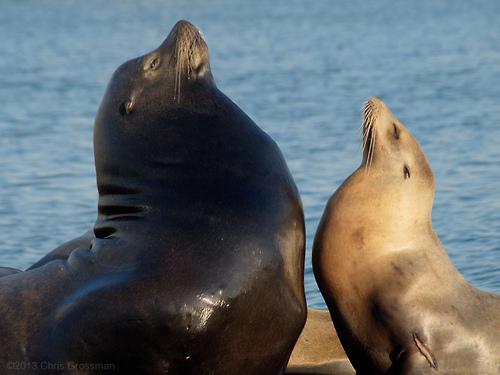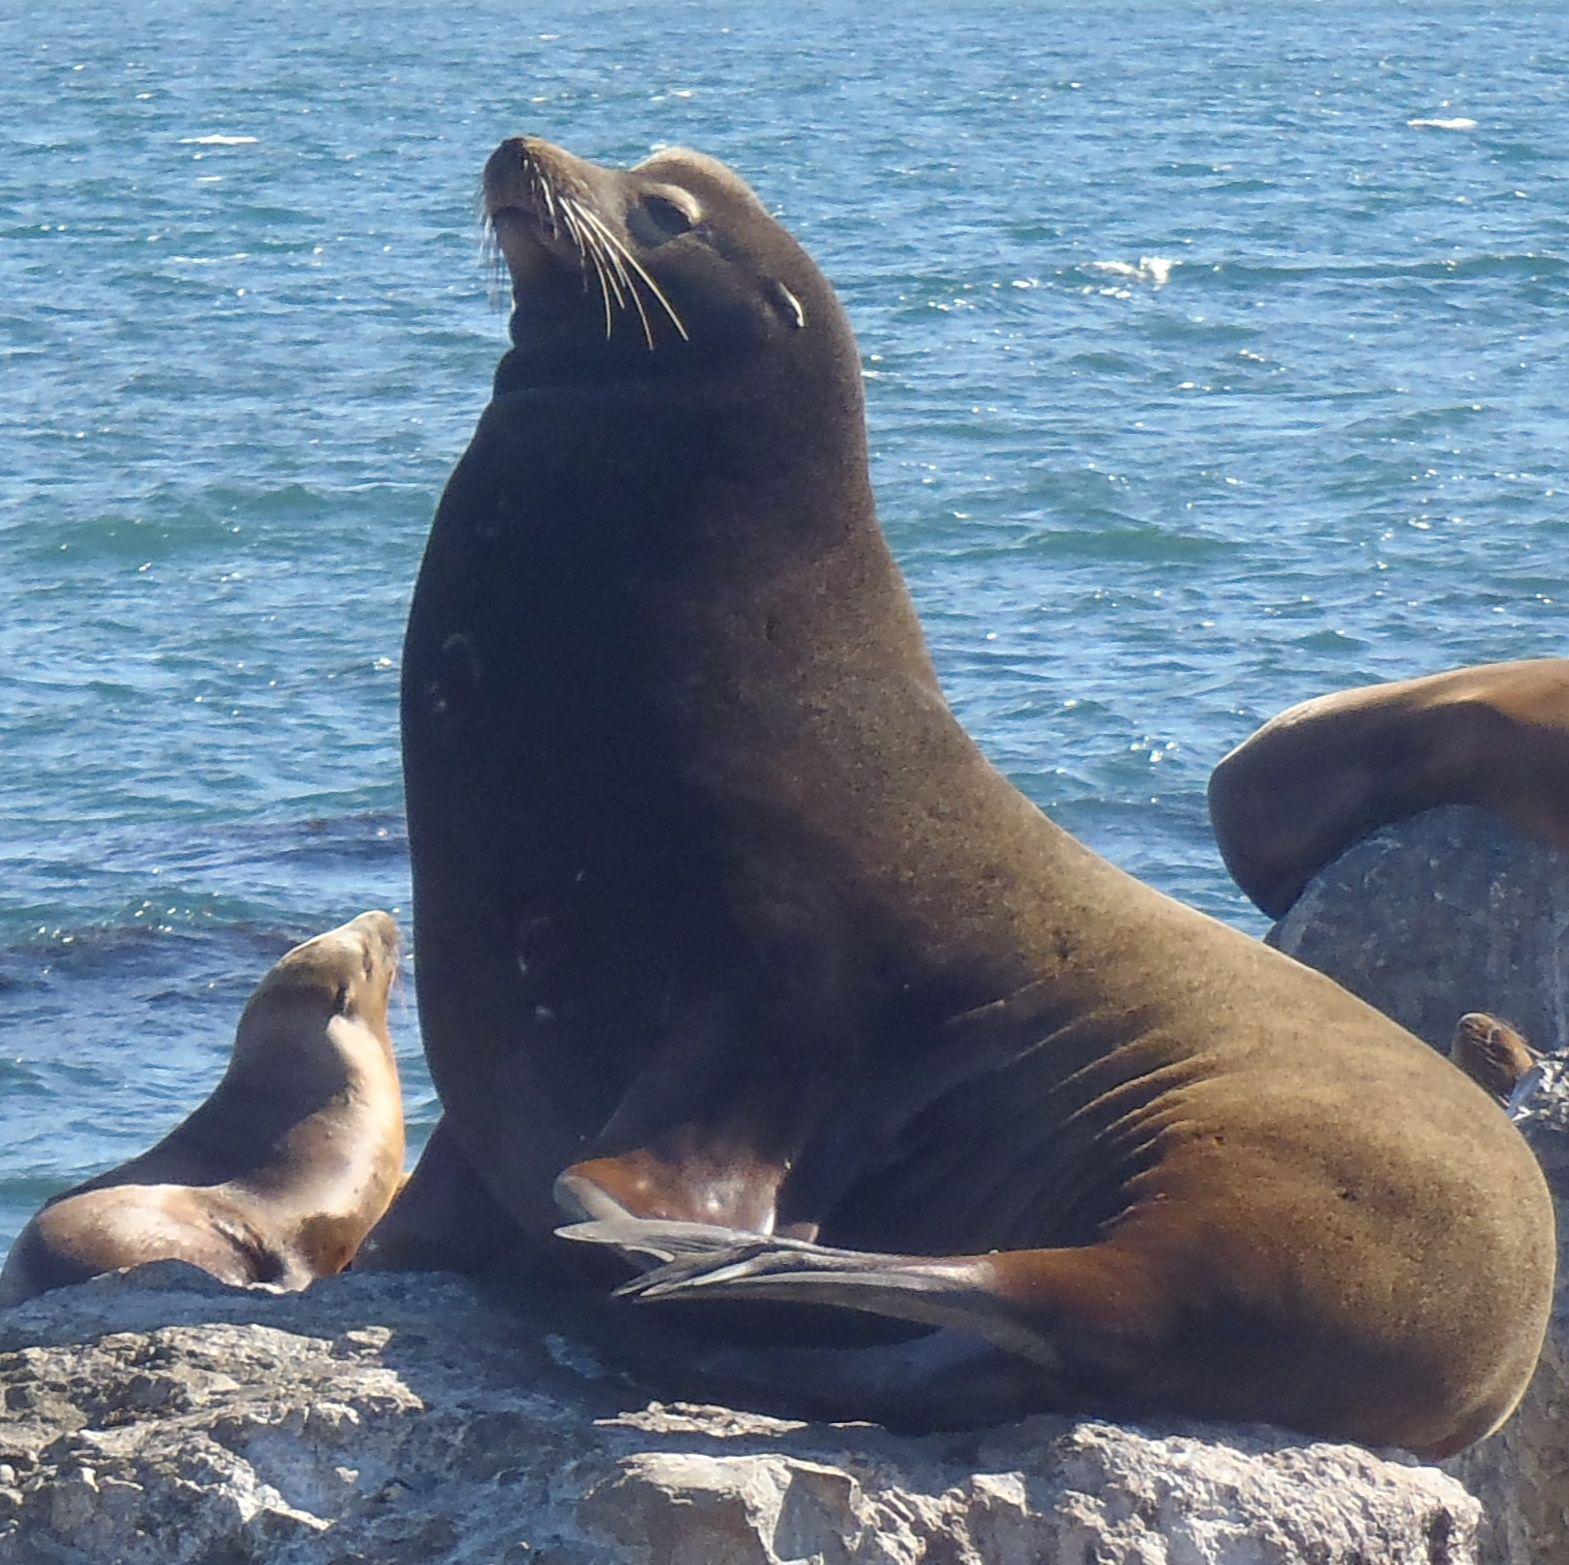The first image is the image on the left, the second image is the image on the right. Assess this claim about the two images: "Left image shows two seals with upraised heads, one large and dark, and the other smaller and paler.". Correct or not? Answer yes or no. Yes. 